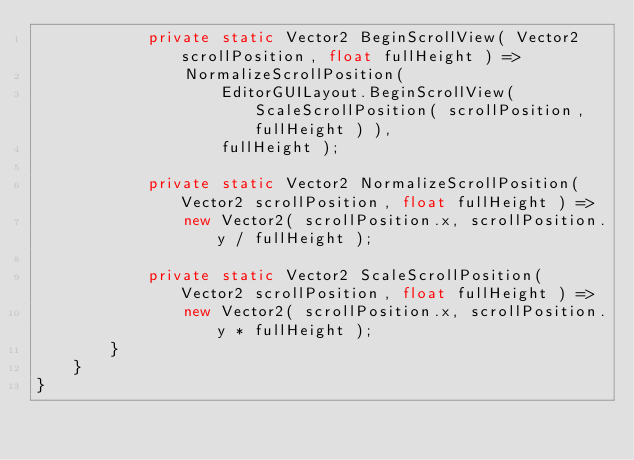Convert code to text. <code><loc_0><loc_0><loc_500><loc_500><_C#_>            private static Vector2 BeginScrollView( Vector2 scrollPosition, float fullHeight ) =>
                NormalizeScrollPosition(
                    EditorGUILayout.BeginScrollView( ScaleScrollPosition( scrollPosition, fullHeight ) ),
                    fullHeight );

            private static Vector2 NormalizeScrollPosition( Vector2 scrollPosition, float fullHeight ) =>
                new Vector2( scrollPosition.x, scrollPosition.y / fullHeight );

            private static Vector2 ScaleScrollPosition( Vector2 scrollPosition, float fullHeight ) =>
                new Vector2( scrollPosition.x, scrollPosition.y * fullHeight );
        }
    }
}</code> 